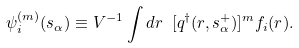<formula> <loc_0><loc_0><loc_500><loc_500>\psi _ { i } ^ { ( m ) } ( s _ { \alpha } ) \equiv V ^ { - 1 } \int d r \ [ q ^ { \dag } ( r , s _ { \alpha } ^ { + } ) ] ^ { m } f _ { i } ( r ) .</formula> 